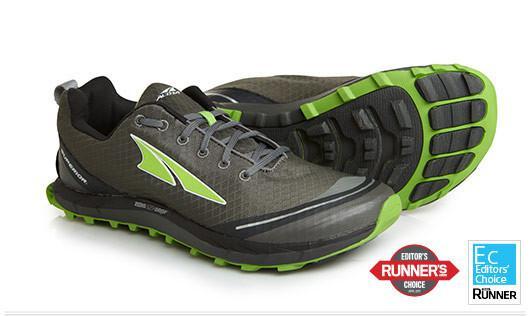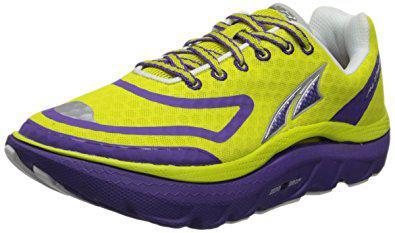The first image is the image on the left, the second image is the image on the right. Given the left and right images, does the statement "One of the three sneakers has yellow shoe laces and it is not laying on it's side." hold true? Answer yes or no. Yes. The first image is the image on the left, the second image is the image on the right. Assess this claim about the two images: "In at least one photo there is a teal shoe with gray trimming and yellow laces facing right.". Correct or not? Answer yes or no. No. 